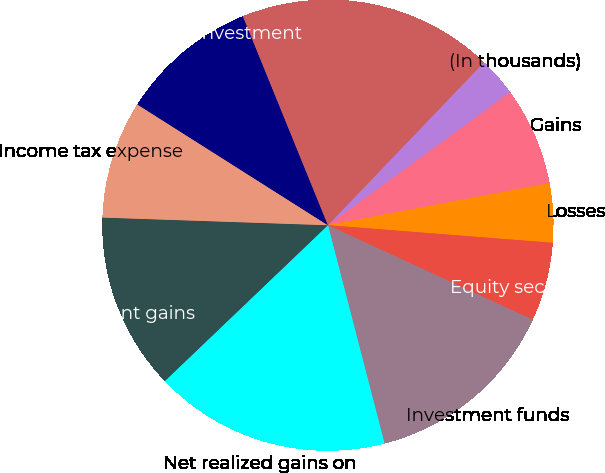<chart> <loc_0><loc_0><loc_500><loc_500><pie_chart><fcel>(In thousands)<fcel>Gains<fcel>Losses<fcel>Equity securities available<fcel>Investment funds<fcel>Net realized gains on<fcel>Net investment gains<fcel>Income tax expense<fcel>After-tax realized investment<fcel>Fixed maturity securities<nl><fcel>2.82%<fcel>7.04%<fcel>4.23%<fcel>5.64%<fcel>14.08%<fcel>16.9%<fcel>12.68%<fcel>8.45%<fcel>9.86%<fcel>18.31%<nl></chart> 